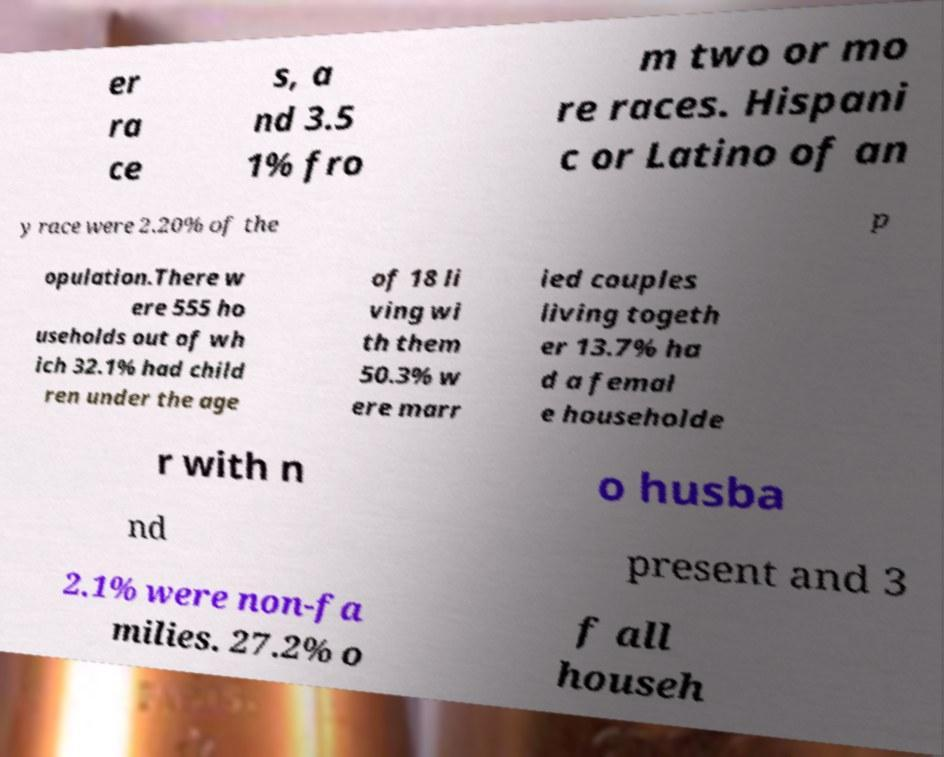I need the written content from this picture converted into text. Can you do that? er ra ce s, a nd 3.5 1% fro m two or mo re races. Hispani c or Latino of an y race were 2.20% of the p opulation.There w ere 555 ho useholds out of wh ich 32.1% had child ren under the age of 18 li ving wi th them 50.3% w ere marr ied couples living togeth er 13.7% ha d a femal e householde r with n o husba nd present and 3 2.1% were non-fa milies. 27.2% o f all househ 